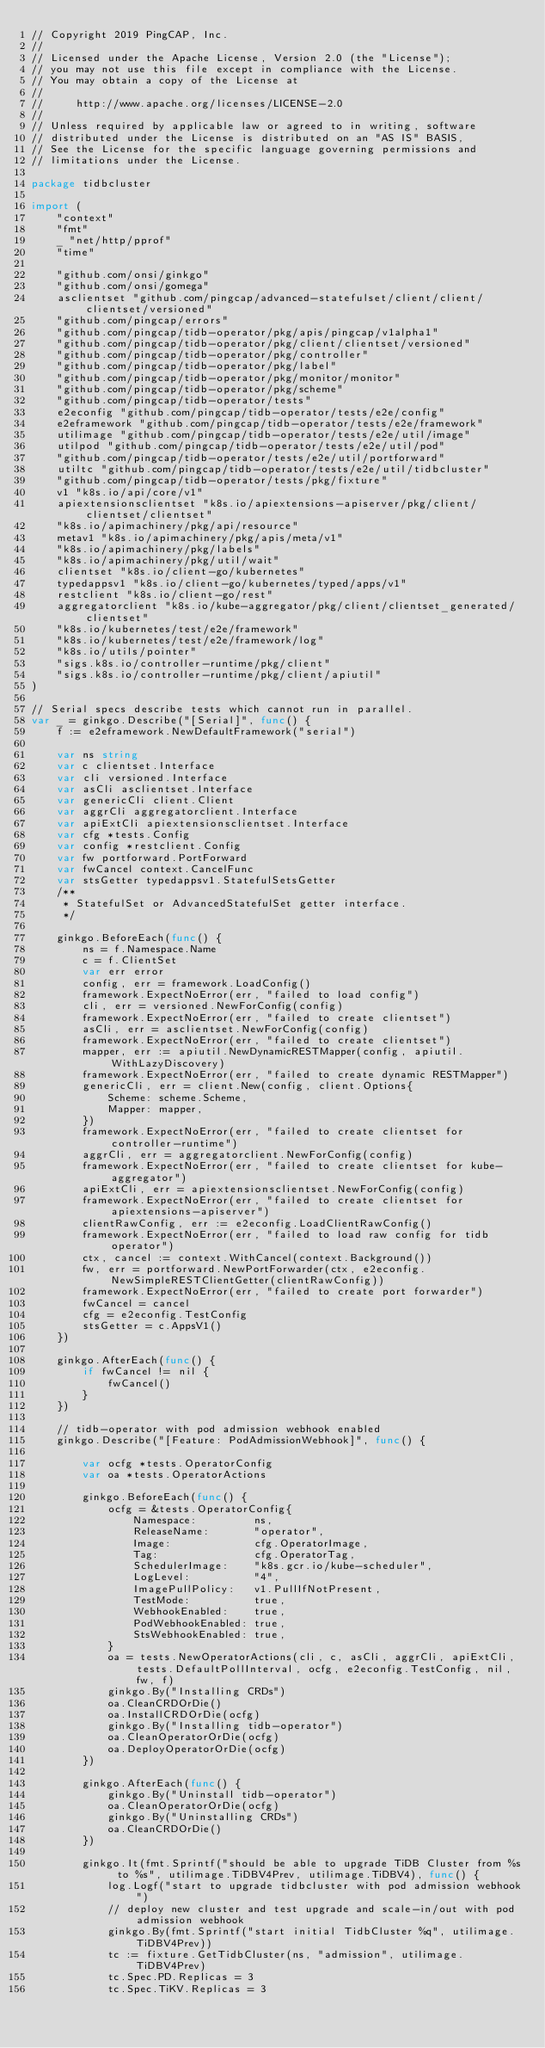<code> <loc_0><loc_0><loc_500><loc_500><_Go_>// Copyright 2019 PingCAP, Inc.
//
// Licensed under the Apache License, Version 2.0 (the "License");
// you may not use this file except in compliance with the License.
// You may obtain a copy of the License at
//
//     http://www.apache.org/licenses/LICENSE-2.0
//
// Unless required by applicable law or agreed to in writing, software
// distributed under the License is distributed on an "AS IS" BASIS,
// See the License for the specific language governing permissions and
// limitations under the License.

package tidbcluster

import (
	"context"
	"fmt"
	_ "net/http/pprof"
	"time"

	"github.com/onsi/ginkgo"
	"github.com/onsi/gomega"
	asclientset "github.com/pingcap/advanced-statefulset/client/client/clientset/versioned"
	"github.com/pingcap/errors"
	"github.com/pingcap/tidb-operator/pkg/apis/pingcap/v1alpha1"
	"github.com/pingcap/tidb-operator/pkg/client/clientset/versioned"
	"github.com/pingcap/tidb-operator/pkg/controller"
	"github.com/pingcap/tidb-operator/pkg/label"
	"github.com/pingcap/tidb-operator/pkg/monitor/monitor"
	"github.com/pingcap/tidb-operator/pkg/scheme"
	"github.com/pingcap/tidb-operator/tests"
	e2econfig "github.com/pingcap/tidb-operator/tests/e2e/config"
	e2eframework "github.com/pingcap/tidb-operator/tests/e2e/framework"
	utilimage "github.com/pingcap/tidb-operator/tests/e2e/util/image"
	utilpod "github.com/pingcap/tidb-operator/tests/e2e/util/pod"
	"github.com/pingcap/tidb-operator/tests/e2e/util/portforward"
	utiltc "github.com/pingcap/tidb-operator/tests/e2e/util/tidbcluster"
	"github.com/pingcap/tidb-operator/tests/pkg/fixture"
	v1 "k8s.io/api/core/v1"
	apiextensionsclientset "k8s.io/apiextensions-apiserver/pkg/client/clientset/clientset"
	"k8s.io/apimachinery/pkg/api/resource"
	metav1 "k8s.io/apimachinery/pkg/apis/meta/v1"
	"k8s.io/apimachinery/pkg/labels"
	"k8s.io/apimachinery/pkg/util/wait"
	clientset "k8s.io/client-go/kubernetes"
	typedappsv1 "k8s.io/client-go/kubernetes/typed/apps/v1"
	restclient "k8s.io/client-go/rest"
	aggregatorclient "k8s.io/kube-aggregator/pkg/client/clientset_generated/clientset"
	"k8s.io/kubernetes/test/e2e/framework"
	"k8s.io/kubernetes/test/e2e/framework/log"
	"k8s.io/utils/pointer"
	"sigs.k8s.io/controller-runtime/pkg/client"
	"sigs.k8s.io/controller-runtime/pkg/client/apiutil"
)

// Serial specs describe tests which cannot run in parallel.
var _ = ginkgo.Describe("[Serial]", func() {
	f := e2eframework.NewDefaultFramework("serial")

	var ns string
	var c clientset.Interface
	var cli versioned.Interface
	var asCli asclientset.Interface
	var genericCli client.Client
	var aggrCli aggregatorclient.Interface
	var apiExtCli apiextensionsclientset.Interface
	var cfg *tests.Config
	var config *restclient.Config
	var fw portforward.PortForward
	var fwCancel context.CancelFunc
	var stsGetter typedappsv1.StatefulSetsGetter
	/**
	 * StatefulSet or AdvancedStatefulSet getter interface.
	 */

	ginkgo.BeforeEach(func() {
		ns = f.Namespace.Name
		c = f.ClientSet
		var err error
		config, err = framework.LoadConfig()
		framework.ExpectNoError(err, "failed to load config")
		cli, err = versioned.NewForConfig(config)
		framework.ExpectNoError(err, "failed to create clientset")
		asCli, err = asclientset.NewForConfig(config)
		framework.ExpectNoError(err, "failed to create clientset")
		mapper, err := apiutil.NewDynamicRESTMapper(config, apiutil.WithLazyDiscovery)
		framework.ExpectNoError(err, "failed to create dynamic RESTMapper")
		genericCli, err = client.New(config, client.Options{
			Scheme: scheme.Scheme,
			Mapper: mapper,
		})
		framework.ExpectNoError(err, "failed to create clientset for controller-runtime")
		aggrCli, err = aggregatorclient.NewForConfig(config)
		framework.ExpectNoError(err, "failed to create clientset for kube-aggregator")
		apiExtCli, err = apiextensionsclientset.NewForConfig(config)
		framework.ExpectNoError(err, "failed to create clientset for apiextensions-apiserver")
		clientRawConfig, err := e2econfig.LoadClientRawConfig()
		framework.ExpectNoError(err, "failed to load raw config for tidb operator")
		ctx, cancel := context.WithCancel(context.Background())
		fw, err = portforward.NewPortForwarder(ctx, e2econfig.NewSimpleRESTClientGetter(clientRawConfig))
		framework.ExpectNoError(err, "failed to create port forwarder")
		fwCancel = cancel
		cfg = e2econfig.TestConfig
		stsGetter = c.AppsV1()
	})

	ginkgo.AfterEach(func() {
		if fwCancel != nil {
			fwCancel()
		}
	})

	// tidb-operator with pod admission webhook enabled
	ginkgo.Describe("[Feature: PodAdmissionWebhook]", func() {

		var ocfg *tests.OperatorConfig
		var oa *tests.OperatorActions

		ginkgo.BeforeEach(func() {
			ocfg = &tests.OperatorConfig{
				Namespace:         ns,
				ReleaseName:       "operator",
				Image:             cfg.OperatorImage,
				Tag:               cfg.OperatorTag,
				SchedulerImage:    "k8s.gcr.io/kube-scheduler",
				LogLevel:          "4",
				ImagePullPolicy:   v1.PullIfNotPresent,
				TestMode:          true,
				WebhookEnabled:    true,
				PodWebhookEnabled: true,
				StsWebhookEnabled: true,
			}
			oa = tests.NewOperatorActions(cli, c, asCli, aggrCli, apiExtCli, tests.DefaultPollInterval, ocfg, e2econfig.TestConfig, nil, fw, f)
			ginkgo.By("Installing CRDs")
			oa.CleanCRDOrDie()
			oa.InstallCRDOrDie(ocfg)
			ginkgo.By("Installing tidb-operator")
			oa.CleanOperatorOrDie(ocfg)
			oa.DeployOperatorOrDie(ocfg)
		})

		ginkgo.AfterEach(func() {
			ginkgo.By("Uninstall tidb-operator")
			oa.CleanOperatorOrDie(ocfg)
			ginkgo.By("Uninstalling CRDs")
			oa.CleanCRDOrDie()
		})

		ginkgo.It(fmt.Sprintf("should be able to upgrade TiDB Cluster from %s to %s", utilimage.TiDBV4Prev, utilimage.TiDBV4), func() {
			log.Logf("start to upgrade tidbcluster with pod admission webhook")
			// deploy new cluster and test upgrade and scale-in/out with pod admission webhook
			ginkgo.By(fmt.Sprintf("start initial TidbCluster %q", utilimage.TiDBV4Prev))
			tc := fixture.GetTidbCluster(ns, "admission", utilimage.TiDBV4Prev)
			tc.Spec.PD.Replicas = 3
			tc.Spec.TiKV.Replicas = 3</code> 